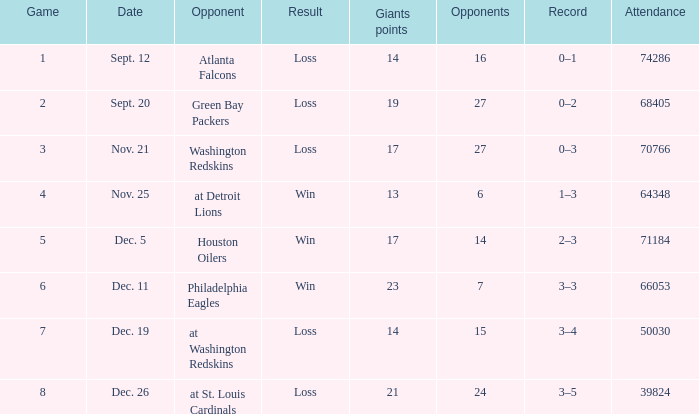What is the smallest number of rivals possible? 6.0. 